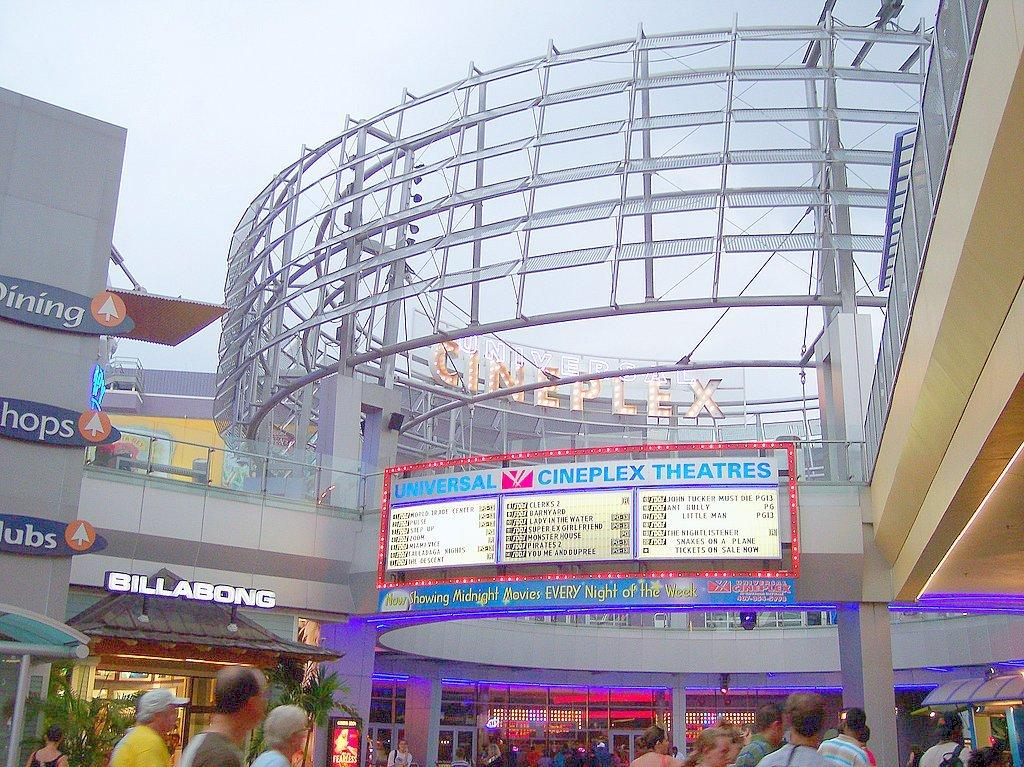What type of building is shown in the picture? There is a shopping mall in the picture. What are the people in the picture doing? There are many people walking in the picture. Can you identify any specific details about the shopping mall? Yes, there are name plates visible in the picture. How would you describe the weather based on the image? The sky is clear in the picture, suggesting good weather. Where is the tub located in the picture? There is no tub present in the image. Can you describe the type of pump used in the field in the picture? There is no field or pump present in the image. 